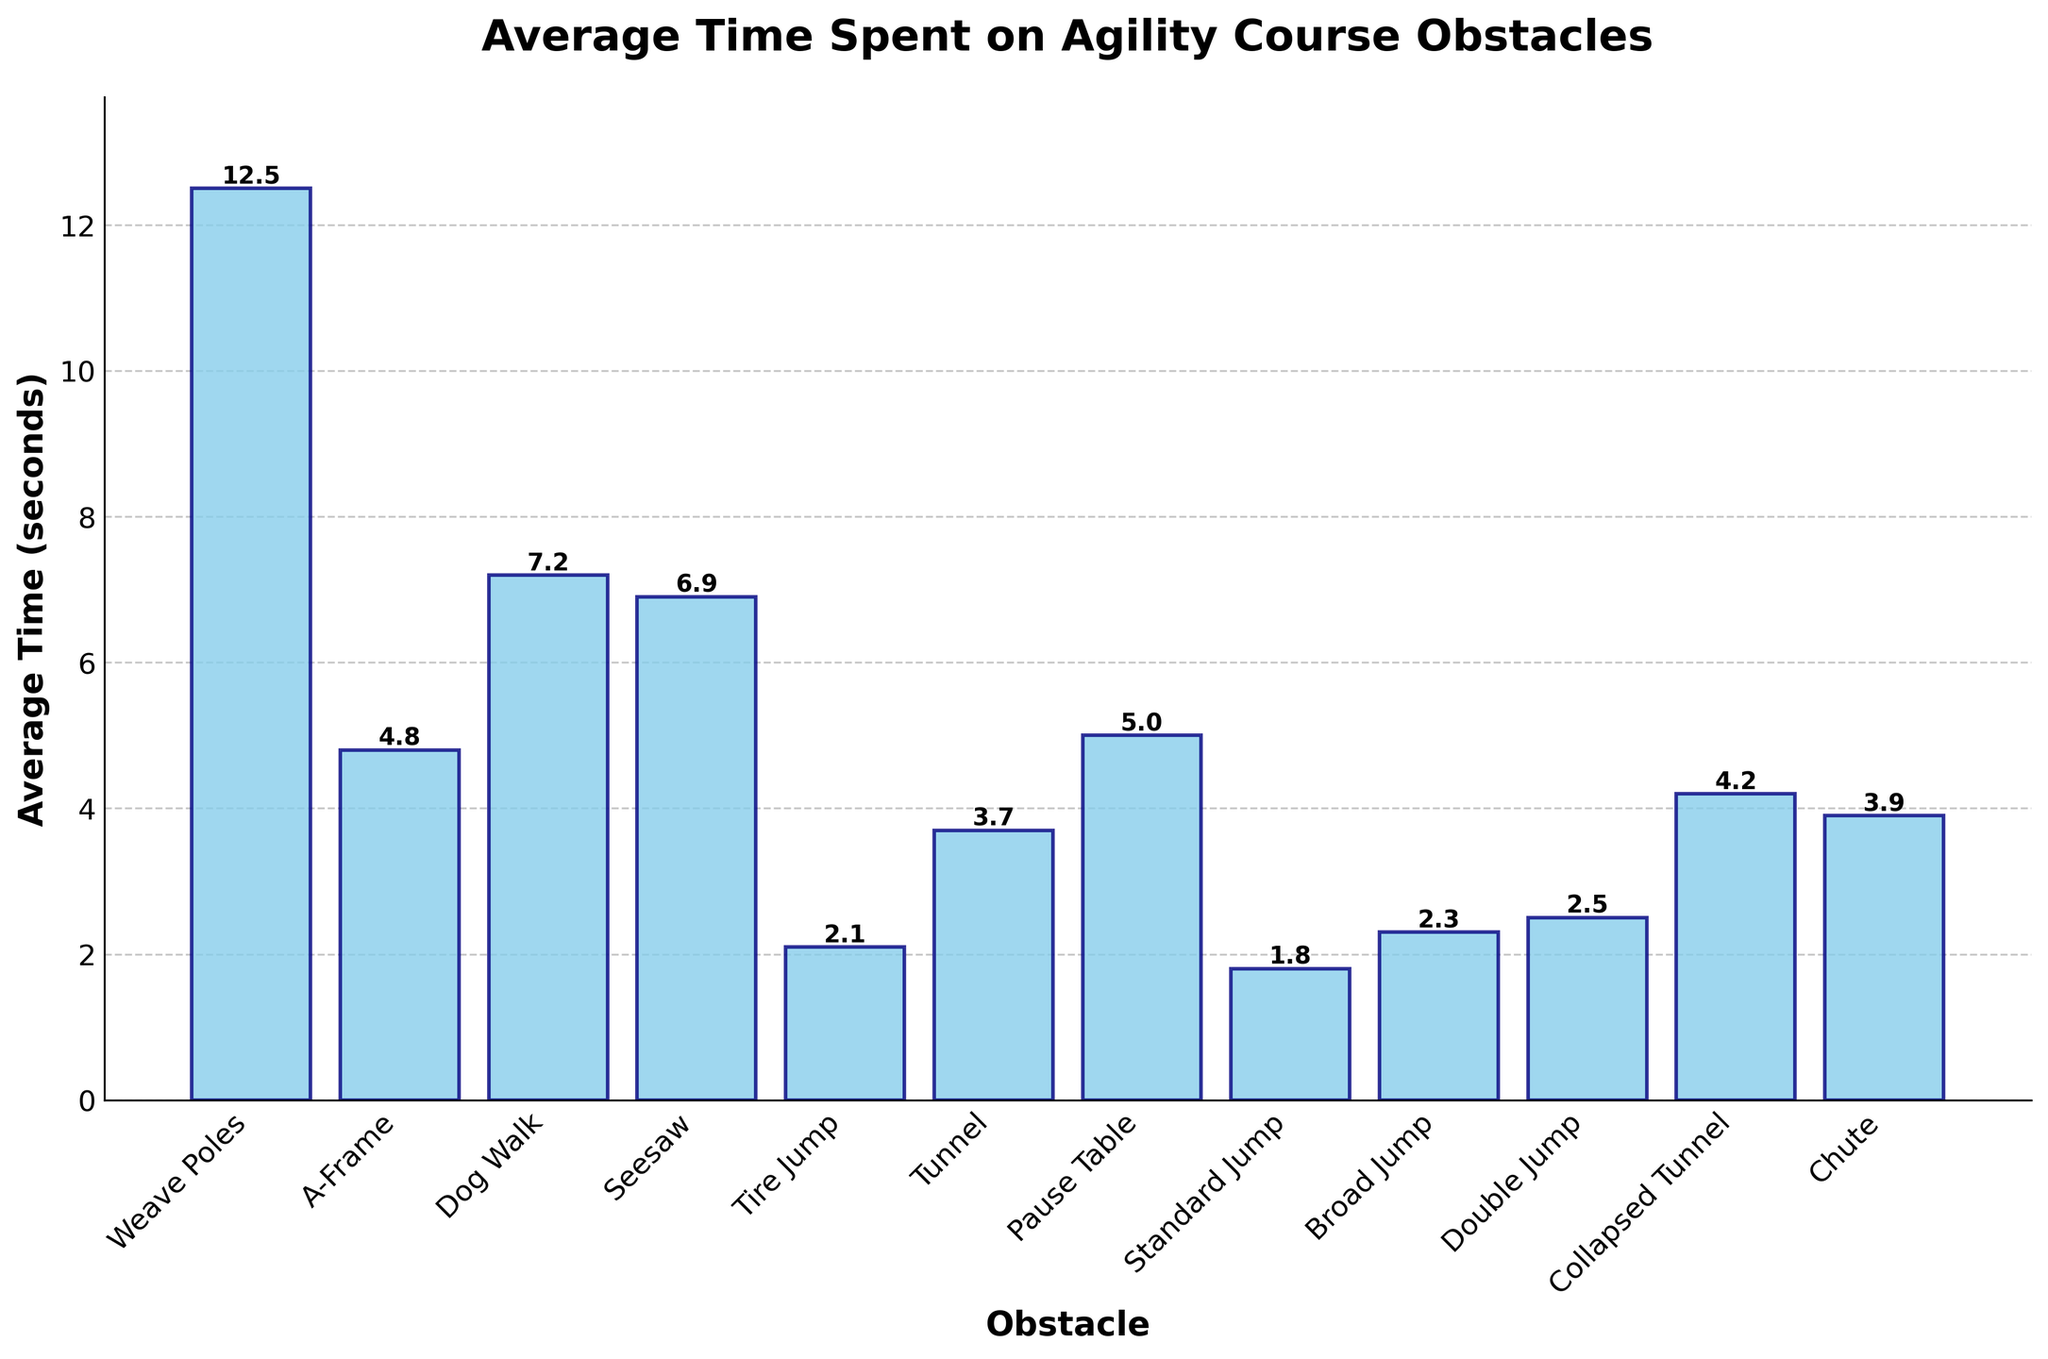Which obstacle takes the longest average time to complete? The obstacle with the highest bar represents the longest average time spent. From the figure, the 'Weave Poles' has the highest bar.
Answer: Weave Poles Which obstacle takes the shortest average time to complete? The obstacle with the shortest bar represents the shortest average time spent. From the figure, the 'Standard Jump' has the shortest bar.
Answer: Standard Jump How much longer does it take on average to complete the 'Weave Poles' compared to the 'Standard Jump'? To find this, subtract the average time of the 'Standard Jump' from the 'Weave Poles'. The 'Weave Poles' is 12.5 seconds, and the 'Standard Jump' is 1.8 seconds. So, 12.5 - 1.8 = 10.7 seconds.
Answer: 10.7 seconds What is the combined average time for 'A-Frame' and 'Seesaw'? Add the average times of 'A-Frame' and 'Seesaw'. The 'A-Frame' is 4.8 seconds and the 'Seesaw' is 6.9 seconds. Therefore, 4.8 + 6.9 = 11.7 seconds.
Answer: 11.7 seconds What is the average time for the obstacles involving jumps (Tire Jump, Standard Jump, Broad Jump, Double Jump)? Sum the average times of 'Tire Jump', 'Standard Jump', 'Broad Jump', and 'Double Jump', then divide by 4. (2.1 + 1.8 + 2.3 + 2.5) / 4 = 8.7 / 4 = 2.175 seconds.
Answer: 2.175 seconds Which obstacle is completed quicker on average: 'Tunnel' or 'Pause Table'? Compare the heights of the bars for 'Tunnel' and 'Pause Table'. From the figure, the 'Tunnel' takes 3.7 seconds and the 'Pause Table' takes 5.0 seconds. Since 3.7 is less than 5.0, the 'Tunnel' is quicker.
Answer: Tunnel What is the total average time taken to complete the 'Dog Walk' and 'Collapsed Tunnel'? Sum the average times of 'Dog Walk' and 'Collapsed Tunnel'. 'Dog Walk' is 7.2 seconds and 'Collapsed Tunnel' is 4.2 seconds. So, 7.2 + 4.2 = 11.4 seconds.
Answer: 11.4 seconds How many obstacles have an average time that is less than 3 seconds? Identify the bars with heights less than 3 seconds. From the figure, three obstacles meet this criterion: 'Tire Jump' (2.1), 'Standard Jump' (1.8), and 'Broad Jump' (2.3).
Answer: 3 obstacles Between 'Chute' and 'Seesaw', which obstacle requires more time on average? Compare the heights of the bars for 'Chute' and 'Seesaw'. From the figure, the 'Seesaw' (6.9 seconds) takes more time than 'Chute' (3.9 seconds).
Answer: Seesaw What is the difference in average time between 'Dog Walk' and 'Tunnel'? Subtract the average time of 'Tunnel' from 'Dog Walk'. 'Dog Walk' is 7.2 seconds and 'Tunnel' is 3.7 seconds. So, 7.2 - 3.7 = 3.5 seconds.
Answer: 3.5 seconds 